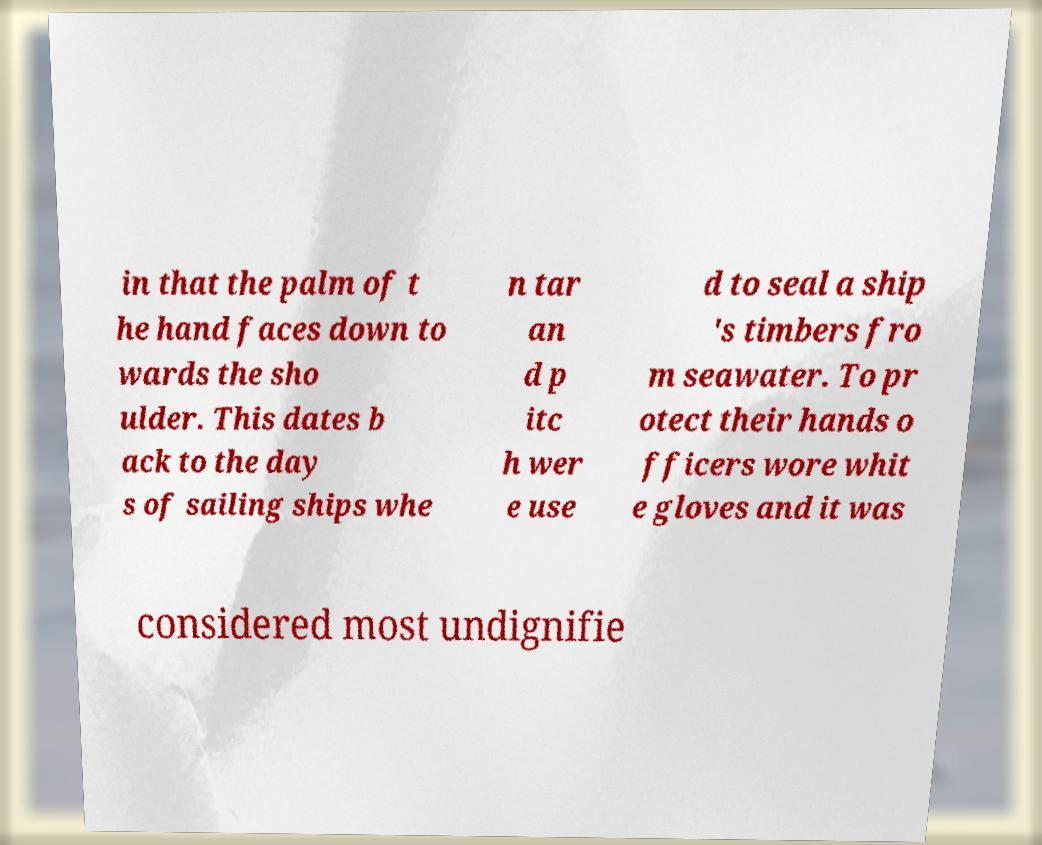There's text embedded in this image that I need extracted. Can you transcribe it verbatim? in that the palm of t he hand faces down to wards the sho ulder. This dates b ack to the day s of sailing ships whe n tar an d p itc h wer e use d to seal a ship 's timbers fro m seawater. To pr otect their hands o fficers wore whit e gloves and it was considered most undignifie 